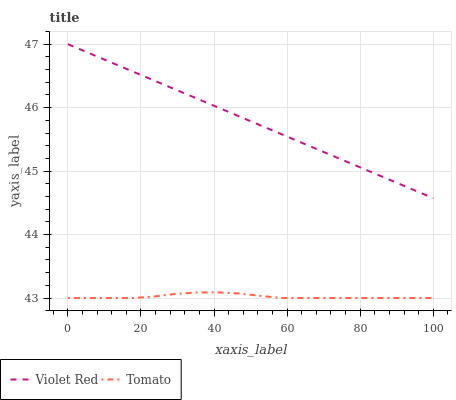Does Violet Red have the minimum area under the curve?
Answer yes or no. No. Is Violet Red the roughest?
Answer yes or no. No. Does Violet Red have the lowest value?
Answer yes or no. No. Is Tomato less than Violet Red?
Answer yes or no. Yes. Is Violet Red greater than Tomato?
Answer yes or no. Yes. Does Tomato intersect Violet Red?
Answer yes or no. No. 